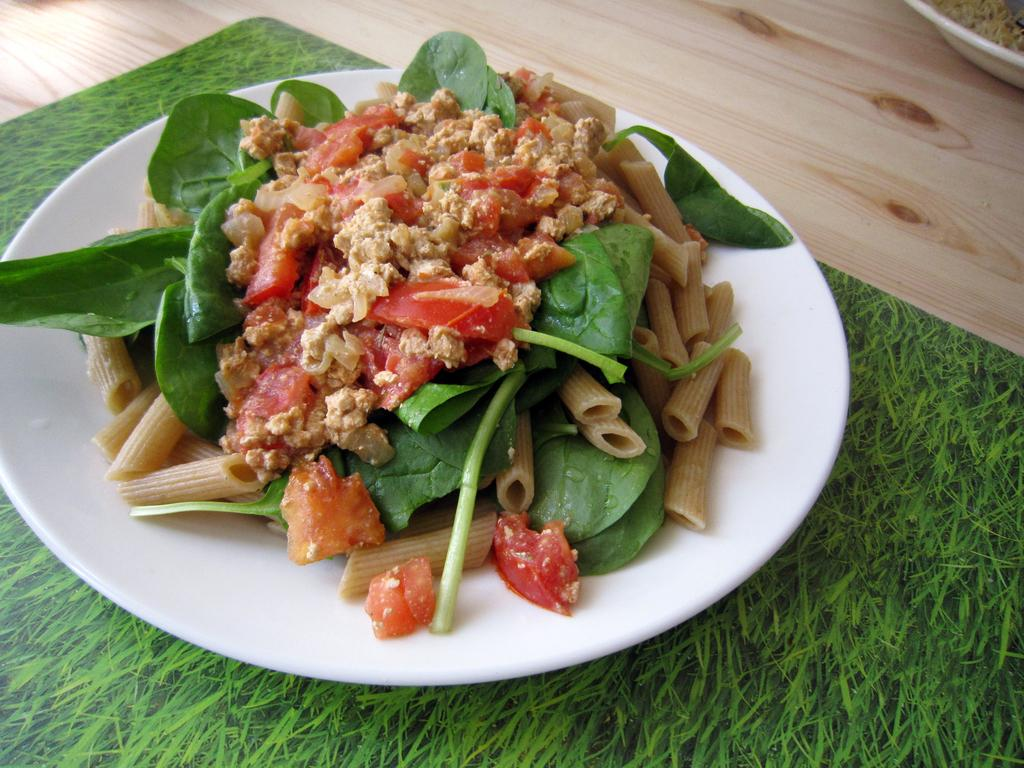What is present on the plates in the image? There are food items on plates in the image. How many plates can be seen in the image? There are plates visible in the image. What is the surface on which the board is placed in the image? The board is on the wooden floor in the image. What type of ground is visible beneath the board in the image? There is no ground visible beneath the board in the image; it is placed on a wooden floor. Can you describe the breathing pattern of the food items on the plates? Food items do not have a breathing pattern, as they are inanimate objects. 